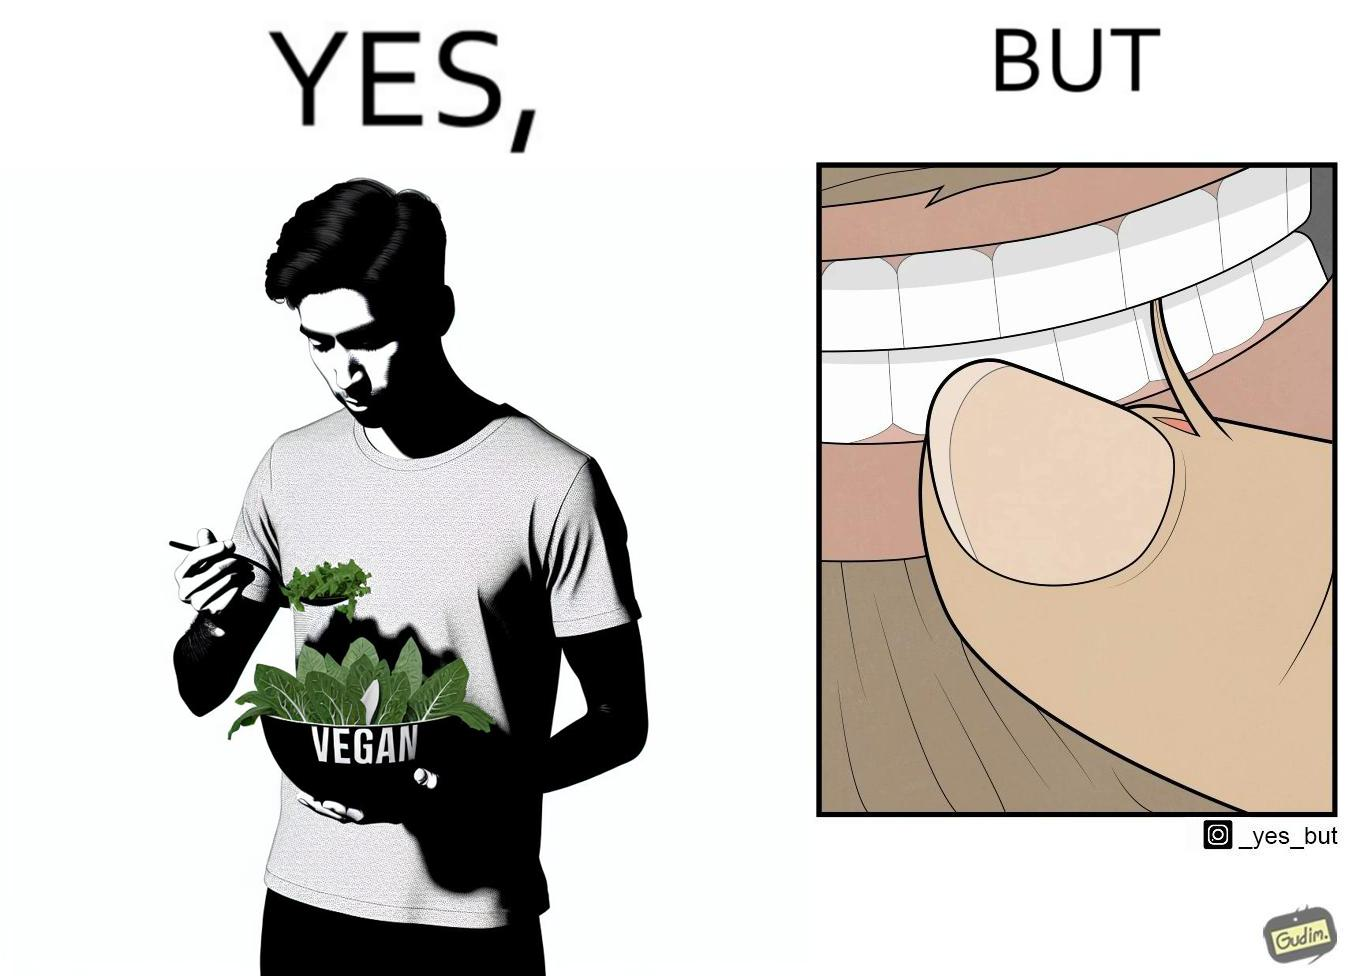Explain why this image is satirical. The image is funny because while the man claims to be vegan, he is biting skin off his own hand. 